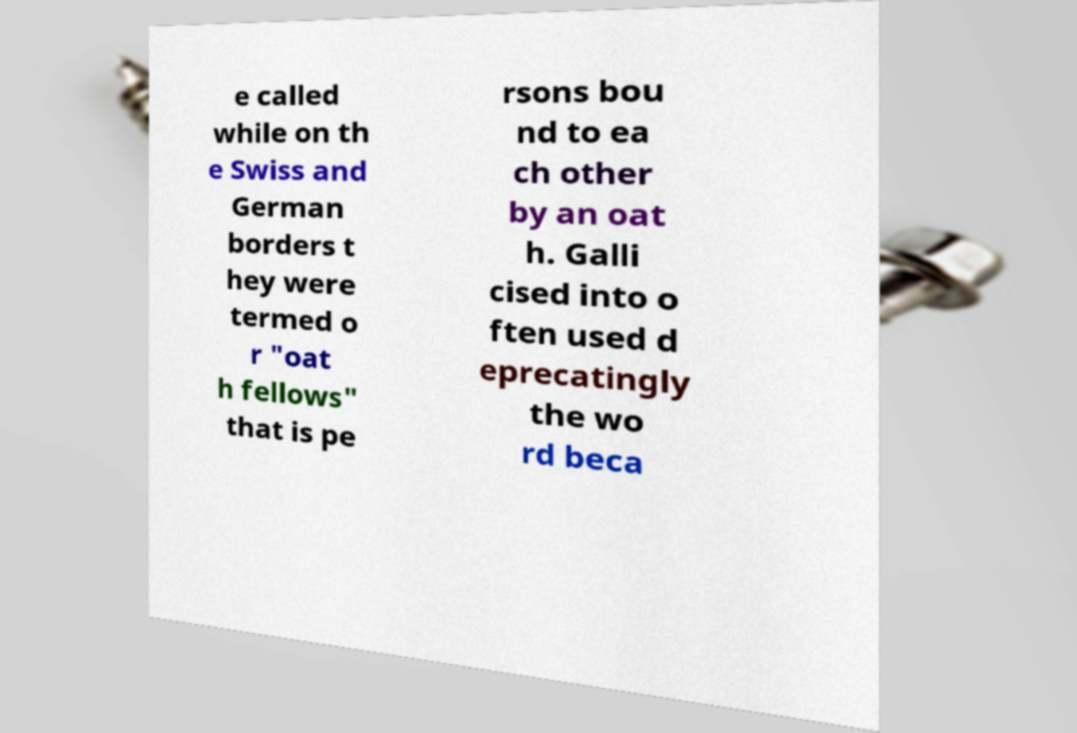Please identify and transcribe the text found in this image. e called while on th e Swiss and German borders t hey were termed o r "oat h fellows" that is pe rsons bou nd to ea ch other by an oat h. Galli cised into o ften used d eprecatingly the wo rd beca 